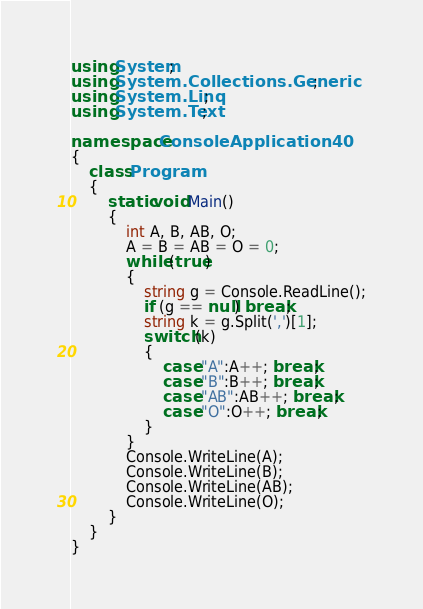<code> <loc_0><loc_0><loc_500><loc_500><_C#_>using System;
using System.Collections.Generic;
using System.Linq;
using System.Text;

namespace ConsoleApplication40
{
    class Program
    {
        static void Main()
        {
            int A, B, AB, O;
            A = B = AB = O = 0;
            while (true)
            {
                string g = Console.ReadLine();
                if (g == null) break;
                string k = g.Split(',')[1];
                switch (k)
                {
                    case "A":A++; break;
                    case "B":B++; break;
                    case "AB":AB++; break;
                    case "O":O++; break;
                }
            }
            Console.WriteLine(A);
            Console.WriteLine(B);
            Console.WriteLine(AB);
            Console.WriteLine(O);
        }
    }
}</code> 